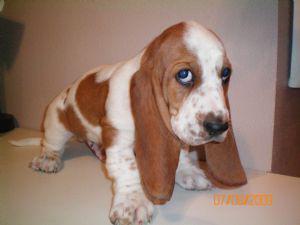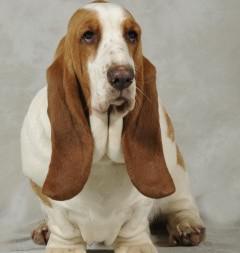The first image is the image on the left, the second image is the image on the right. Examine the images to the left and right. Is the description "At least one of the dogs is outside." accurate? Answer yes or no. No. The first image is the image on the left, the second image is the image on the right. Given the left and right images, does the statement "There is green vegetation visible in the background of at least one of the images." hold true? Answer yes or no. No. 